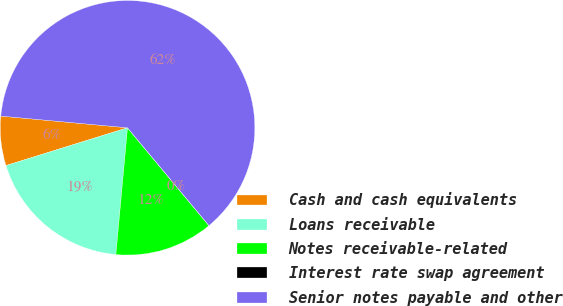Convert chart to OTSL. <chart><loc_0><loc_0><loc_500><loc_500><pie_chart><fcel>Cash and cash equivalents<fcel>Loans receivable<fcel>Notes receivable-related<fcel>Interest rate swap agreement<fcel>Senior notes payable and other<nl><fcel>6.26%<fcel>18.75%<fcel>12.5%<fcel>0.01%<fcel>62.48%<nl></chart> 